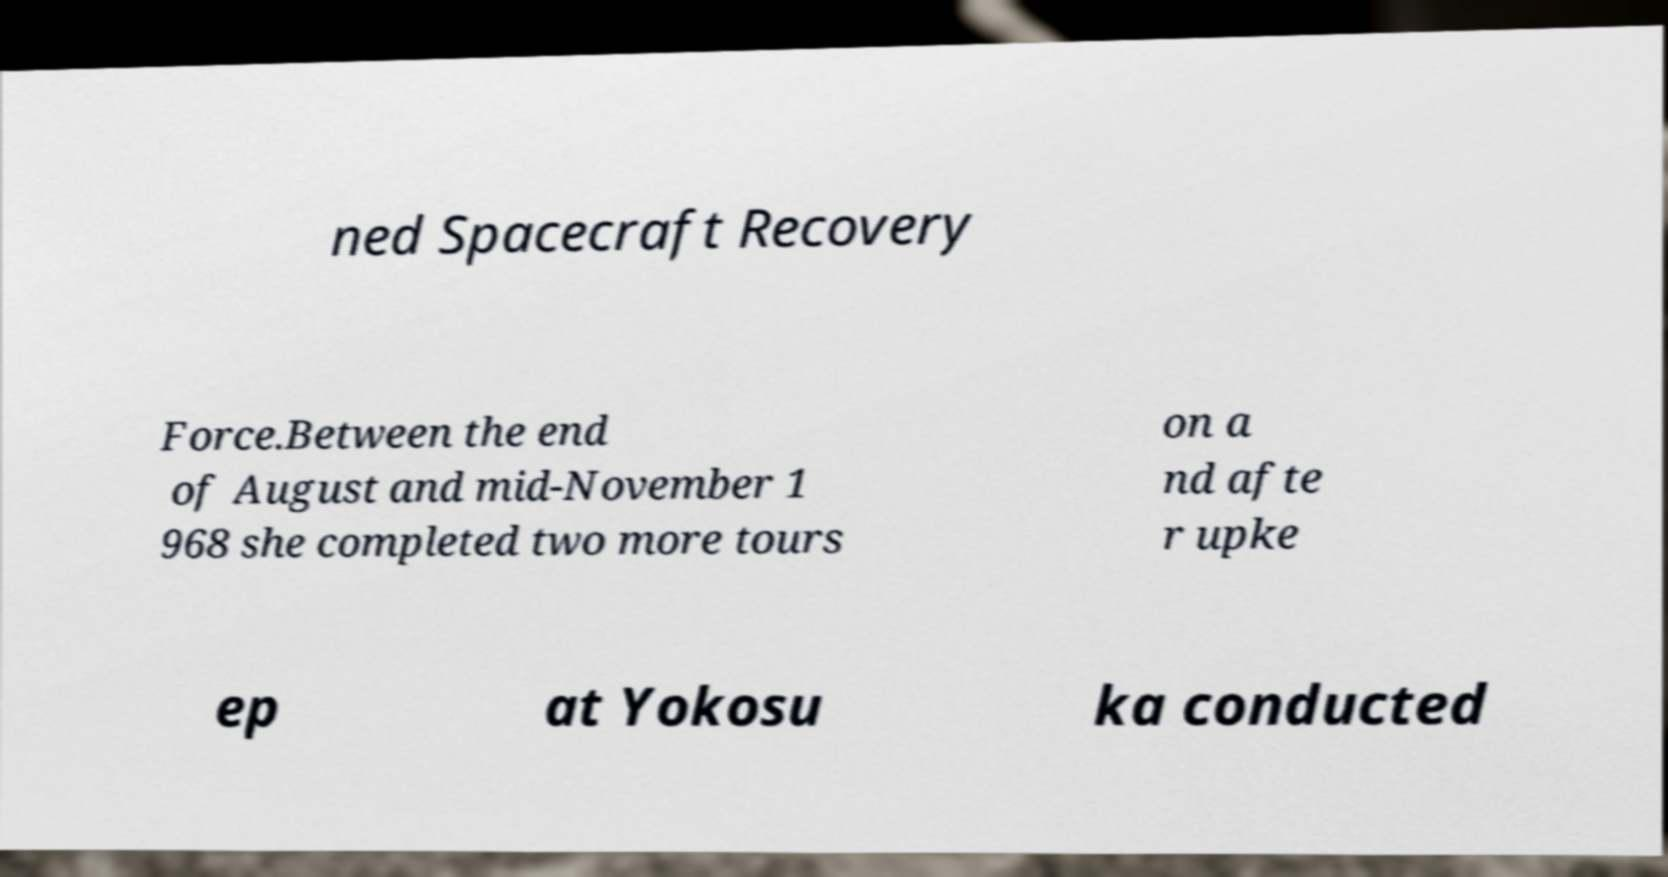Can you accurately transcribe the text from the provided image for me? ned Spacecraft Recovery Force.Between the end of August and mid-November 1 968 she completed two more tours on a nd afte r upke ep at Yokosu ka conducted 